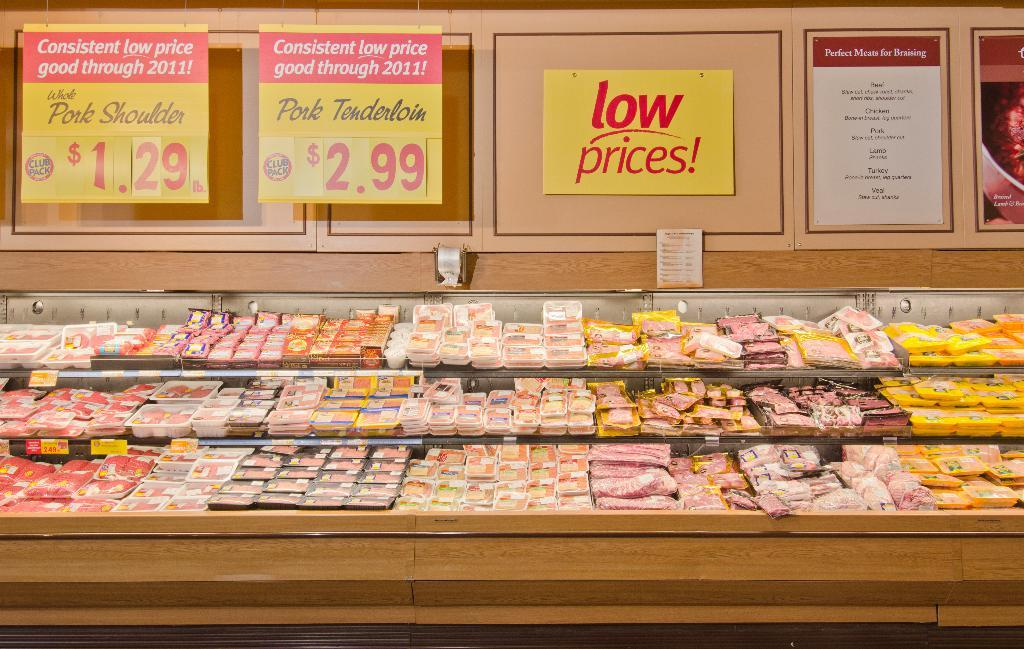<image>
Describe the image concisely. A Yellow signboard in a grocery store advertising Pork Tenderloin for $2.99 